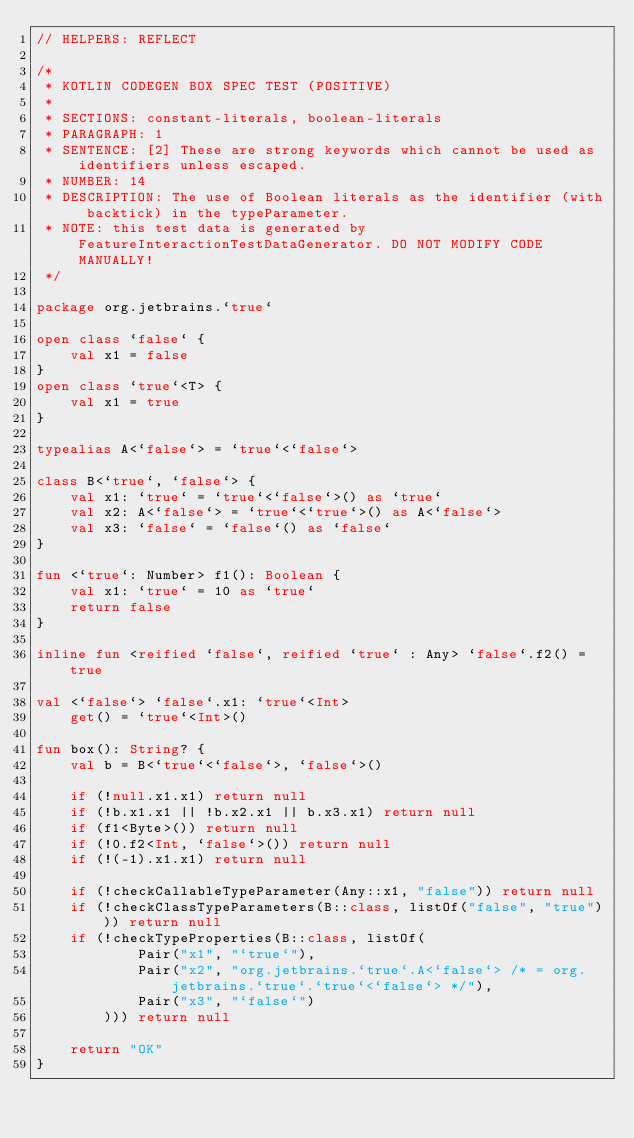Convert code to text. <code><loc_0><loc_0><loc_500><loc_500><_Kotlin_>// HELPERS: REFLECT

/*
 * KOTLIN CODEGEN BOX SPEC TEST (POSITIVE)
 *
 * SECTIONS: constant-literals, boolean-literals
 * PARAGRAPH: 1
 * SENTENCE: [2] These are strong keywords which cannot be used as identifiers unless escaped.
 * NUMBER: 14
 * DESCRIPTION: The use of Boolean literals as the identifier (with backtick) in the typeParameter.
 * NOTE: this test data is generated by FeatureInteractionTestDataGenerator. DO NOT MODIFY CODE MANUALLY!
 */

package org.jetbrains.`true`

open class `false` {
    val x1 = false
}
open class `true`<T> {
    val x1 = true
}

typealias A<`false`> = `true`<`false`>

class B<`true`, `false`> {
    val x1: `true` = `true`<`false`>() as `true`
    val x2: A<`false`> = `true`<`true`>() as A<`false`>
    val x3: `false` = `false`() as `false`
}

fun <`true`: Number> f1(): Boolean {
    val x1: `true` = 10 as `true`
    return false
}

inline fun <reified `false`, reified `true` : Any> `false`.f2() = true

val <`false`> `false`.x1: `true`<Int>
    get() = `true`<Int>()

fun box(): String? {
    val b = B<`true`<`false`>, `false`>()

    if (!null.x1.x1) return null
    if (!b.x1.x1 || !b.x2.x1 || b.x3.x1) return null
    if (f1<Byte>()) return null
    if (!0.f2<Int, `false`>()) return null
    if (!(-1).x1.x1) return null

    if (!checkCallableTypeParameter(Any::x1, "false")) return null
    if (!checkClassTypeParameters(B::class, listOf("false", "true"))) return null
    if (!checkTypeProperties(B::class, listOf(
            Pair("x1", "`true`"),
            Pair("x2", "org.jetbrains.`true`.A<`false`> /* = org.jetbrains.`true`.`true`<`false`> */"),
            Pair("x3", "`false`")
        ))) return null

    return "OK"
}</code> 